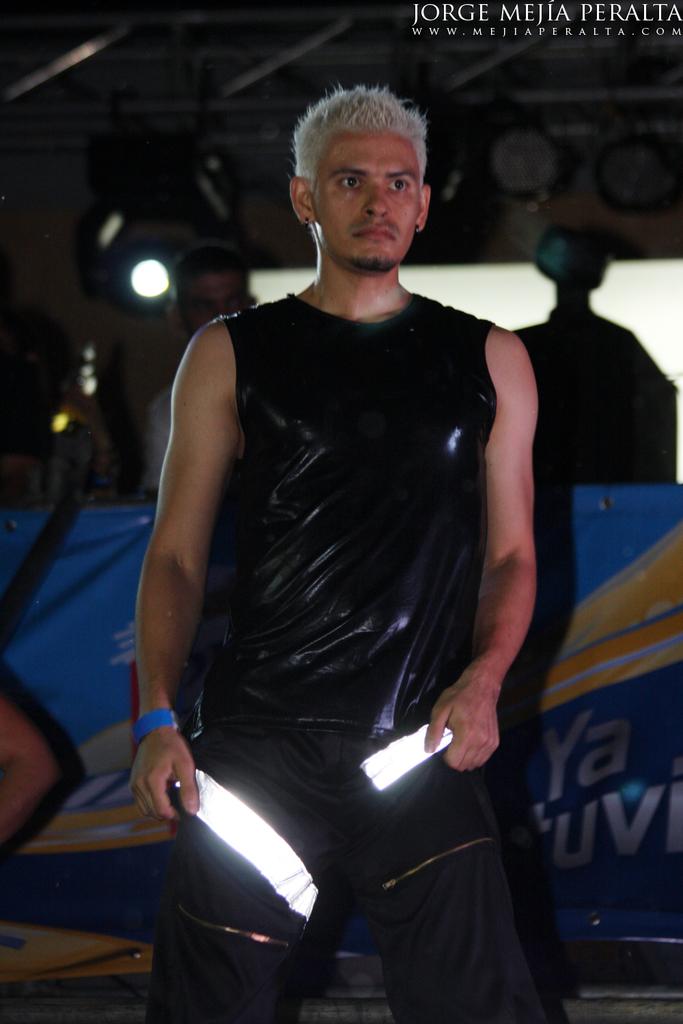What's the full name printed (top right)?
Provide a succinct answer. Jorge mejia peralta. 